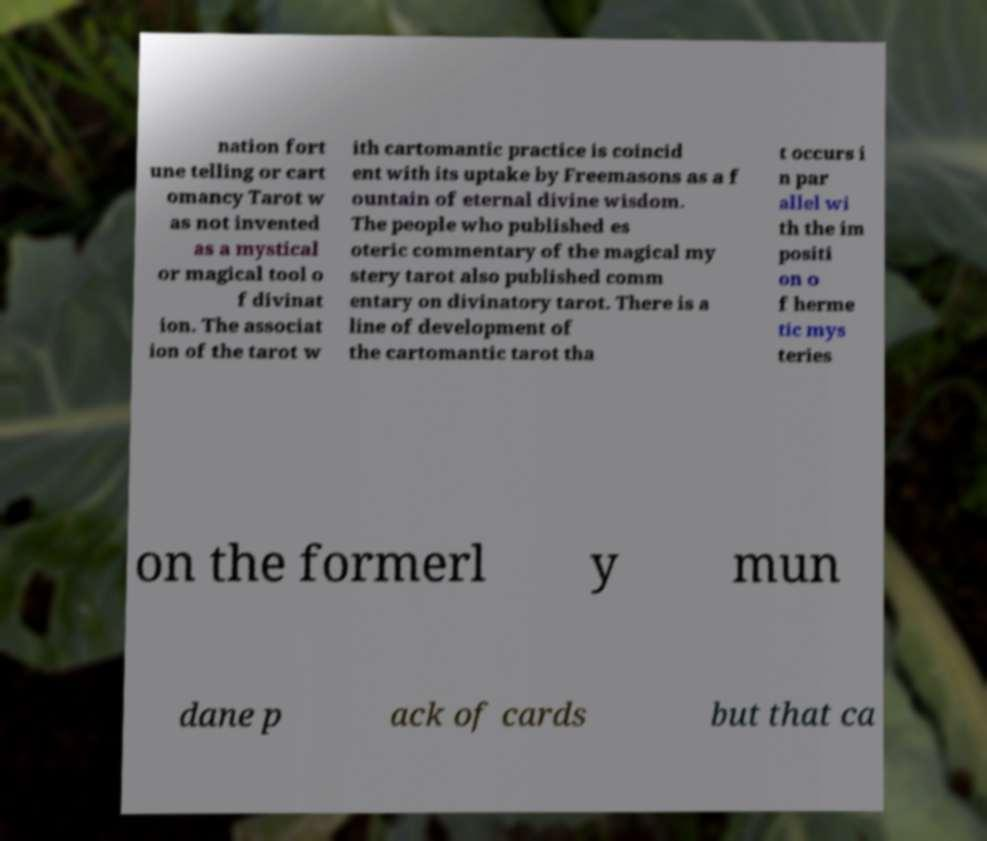What messages or text are displayed in this image? I need them in a readable, typed format. nation fort une telling or cart omancy Tarot w as not invented as a mystical or magical tool o f divinat ion. The associat ion of the tarot w ith cartomantic practice is coincid ent with its uptake by Freemasons as a f ountain of eternal divine wisdom. The people who published es oteric commentary of the magical my stery tarot also published comm entary on divinatory tarot. There is a line of development of the cartomantic tarot tha t occurs i n par allel wi th the im positi on o f herme tic mys teries on the formerl y mun dane p ack of cards but that ca 